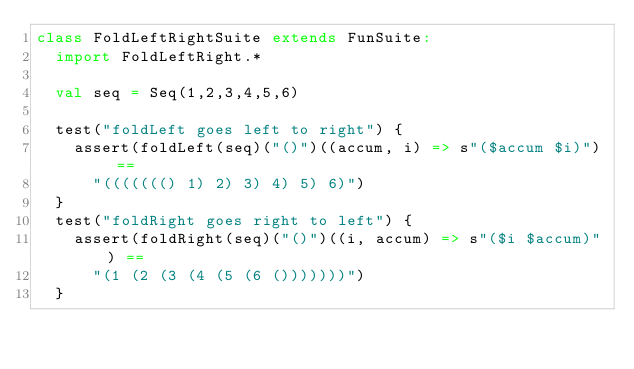<code> <loc_0><loc_0><loc_500><loc_500><_Scala_>class FoldLeftRightSuite extends FunSuite:
  import FoldLeftRight.*

  val seq = Seq(1,2,3,4,5,6)

  test("foldLeft goes left to right") {
    assert(foldLeft(seq)("()")((accum, i) => s"($accum $i)") ==
      "((((((() 1) 2) 3) 4) 5) 6)")
  }
  test("foldRight goes right to left") {
    assert(foldRight(seq)("()")((i, accum) => s"($i $accum)") ==
      "(1 (2 (3 (4 (5 (6 ()))))))")
  }
</code> 